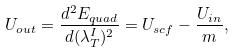<formula> <loc_0><loc_0><loc_500><loc_500>U _ { o u t } = \frac { d ^ { 2 } E _ { q u a d } } { d ( \lambda ^ { I } _ { T } ) ^ { 2 } } = U _ { s c f } - \frac { U _ { i n } } { m } ,</formula> 